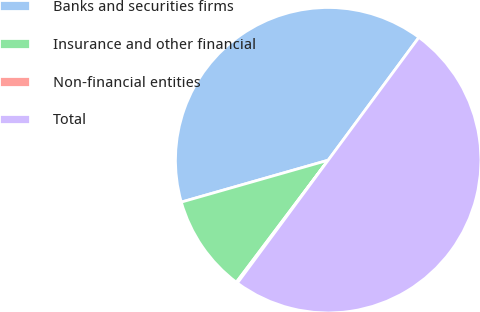<chart> <loc_0><loc_0><loc_500><loc_500><pie_chart><fcel>Banks and securities firms<fcel>Insurance and other financial<fcel>Non-financial entities<fcel>Total<nl><fcel>39.54%<fcel>10.31%<fcel>0.14%<fcel>50.0%<nl></chart> 